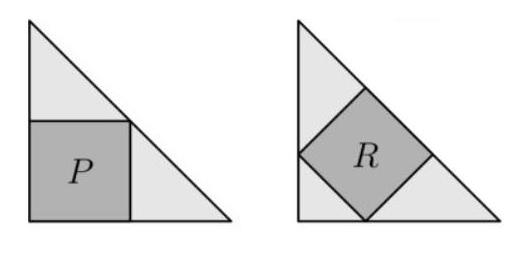One square is drawn inside each of the two congruent isosceles right-angled triangles. The area of square $P$ is 45 units. How many units is the area of square R? To find the area of square R, we need to understand the relationship between the triangles and the squares. Since triangles are congruent and isosceles right-angled, the ratio of the areas of the squares will be the same as the ratio of the sides of the squares. If the area of square P is 45 units, which is 9 squared, it means the side of square P is 9 units. As square R is inside a similar triangle, but at a 45-degree rotation, each side of square R is equal to the length of the side of square P multiplied by the square root of 2 (due to the 45-45-90 right triangle ratio). This makes the new side length 9 * sqrt(2). The area of square R therefore is (9 * sqrt(2))^2 = 81 * 2 = 162 units. So, square R has an area of 162 units. 